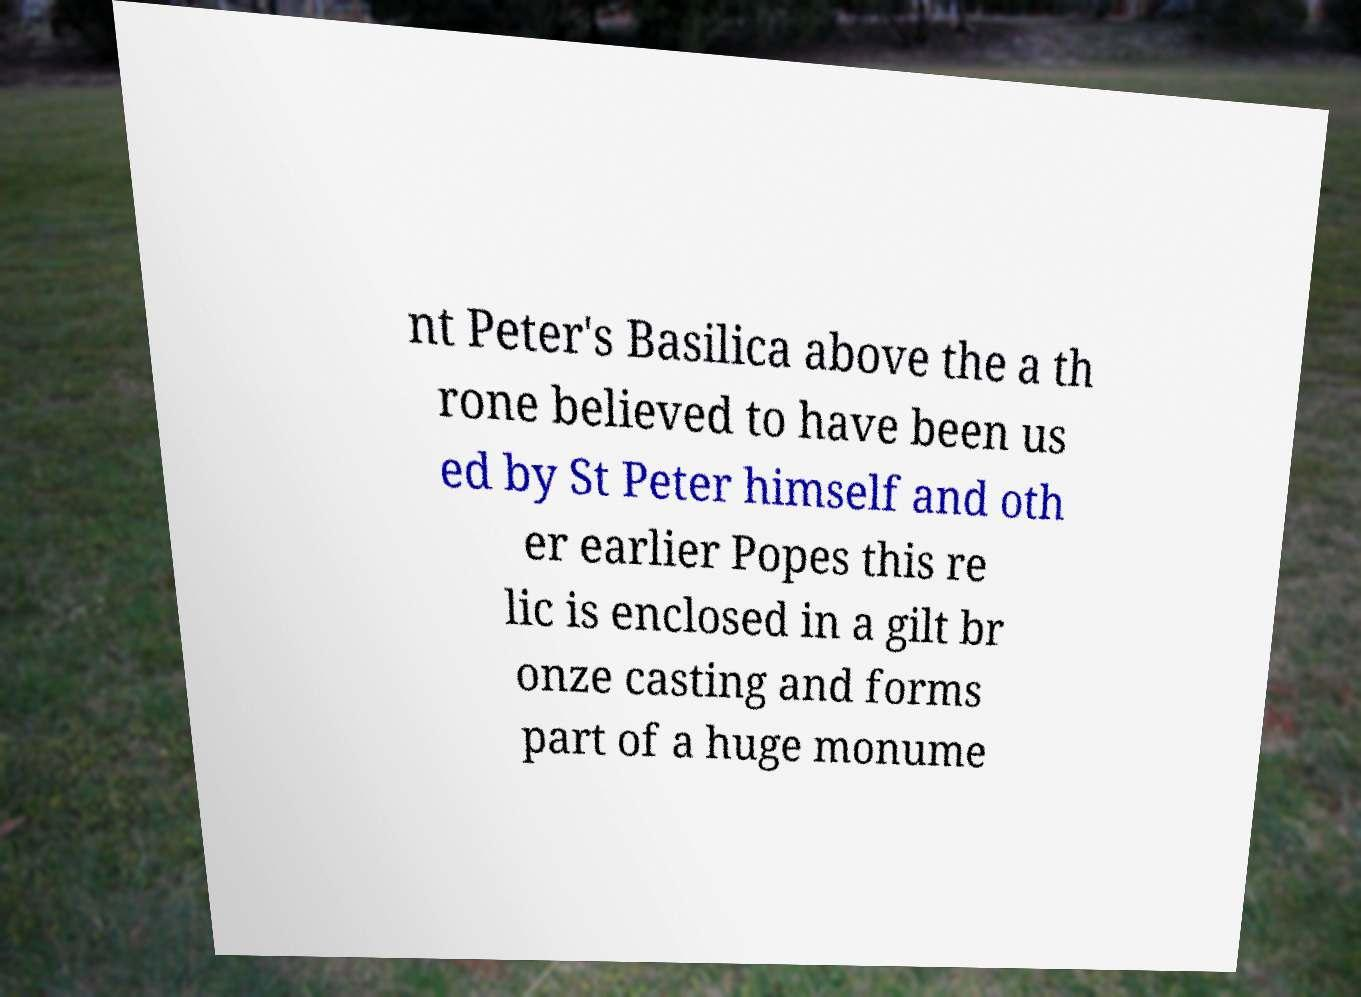I need the written content from this picture converted into text. Can you do that? nt Peter's Basilica above the a th rone believed to have been us ed by St Peter himself and oth er earlier Popes this re lic is enclosed in a gilt br onze casting and forms part of a huge monume 